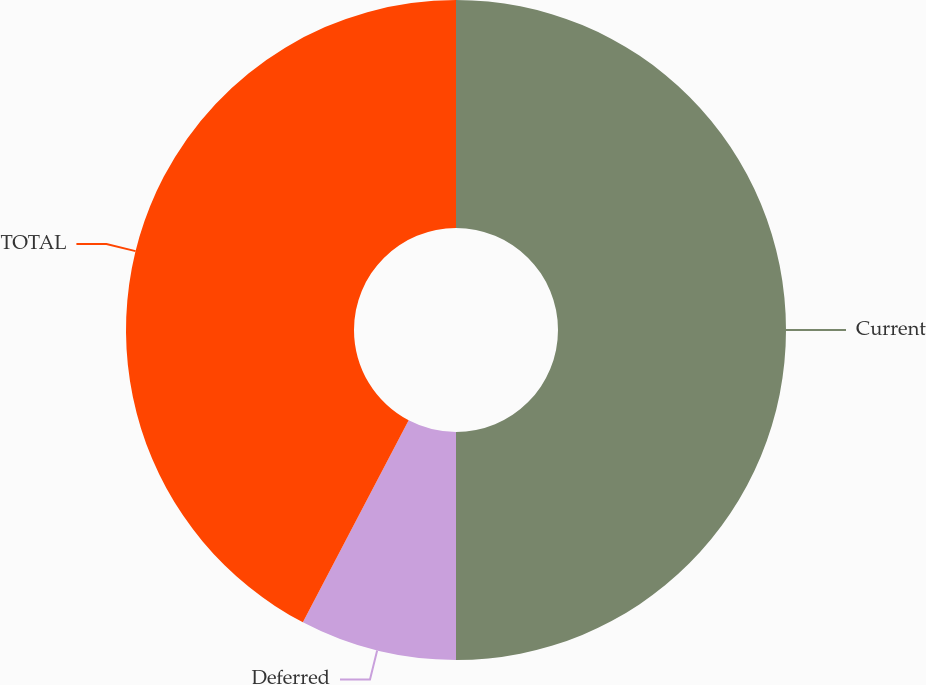<chart> <loc_0><loc_0><loc_500><loc_500><pie_chart><fcel>Current<fcel>Deferred<fcel>TOTAL<nl><fcel>50.0%<fcel>7.68%<fcel>42.32%<nl></chart> 